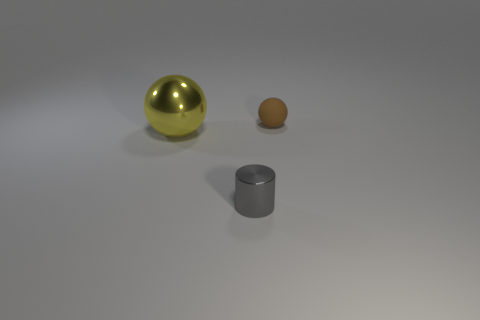Add 1 yellow cubes. How many objects exist? 4 Subtract all balls. How many objects are left? 1 Subtract all small balls. Subtract all tiny yellow objects. How many objects are left? 2 Add 2 small gray metallic objects. How many small gray metallic objects are left? 3 Add 3 metal balls. How many metal balls exist? 4 Subtract 1 yellow balls. How many objects are left? 2 